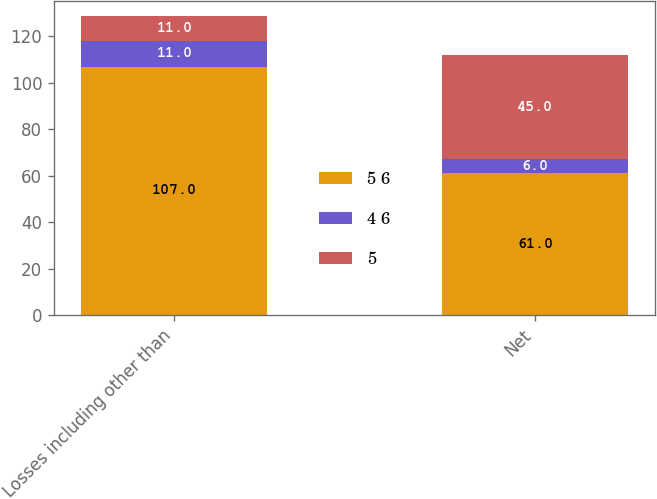Convert chart. <chart><loc_0><loc_0><loc_500><loc_500><stacked_bar_chart><ecel><fcel>Losses including other than<fcel>Net<nl><fcel>5 6<fcel>107<fcel>61<nl><fcel>4 6<fcel>11<fcel>6<nl><fcel>5<fcel>11<fcel>45<nl></chart> 